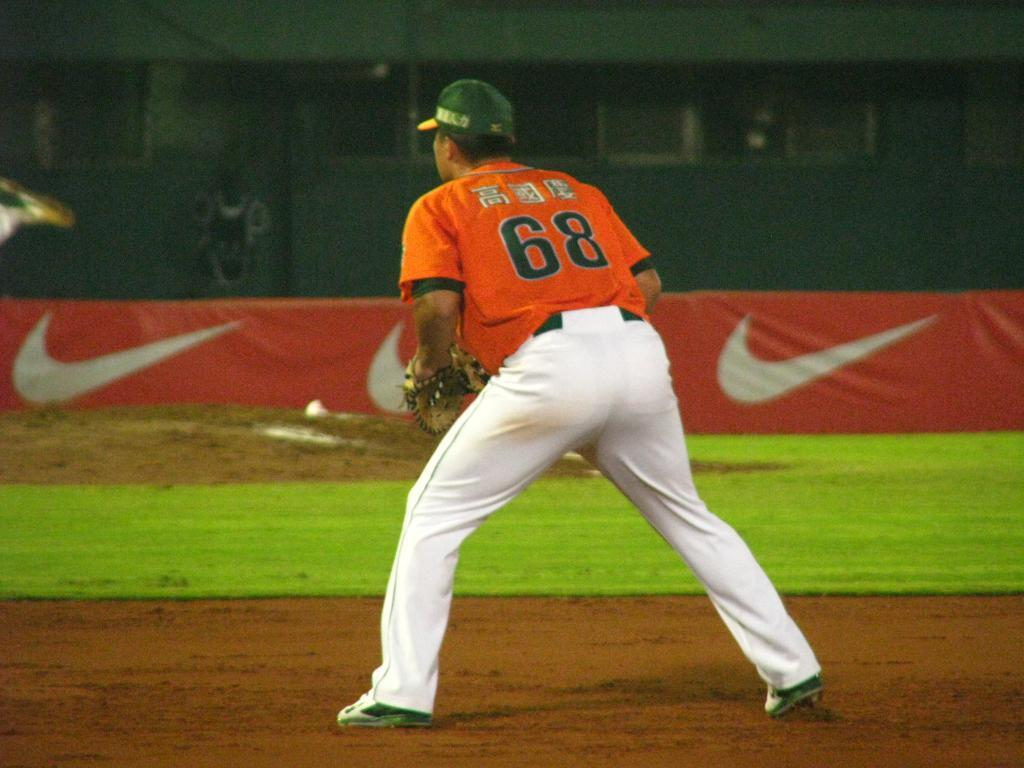<image>
Provide a brief description of the given image. a man with a jersey that has the number 68 on it 